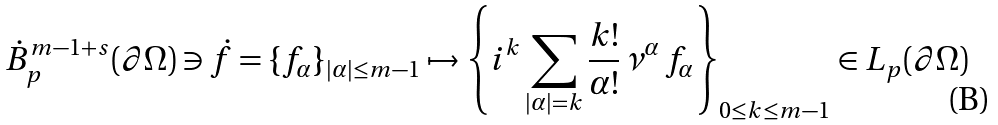<formula> <loc_0><loc_0><loc_500><loc_500>\dot { B } ^ { m - 1 + s } _ { p } ( \partial \Omega ) \ni \dot { f } = \{ f _ { \alpha } \} _ { | \alpha | \leq m - 1 } \mapsto \left \{ i ^ { k } \sum _ { | \alpha | = k } \frac { k ! } { \alpha ! } \, \nu ^ { \alpha } \, f _ { \alpha } \right \} _ { 0 \leq k \leq m - 1 } \in L _ { p } ( \partial \Omega )</formula> 